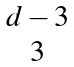<formula> <loc_0><loc_0><loc_500><loc_500>\begin{matrix} d - 3 \\ 3 \end{matrix}</formula> 